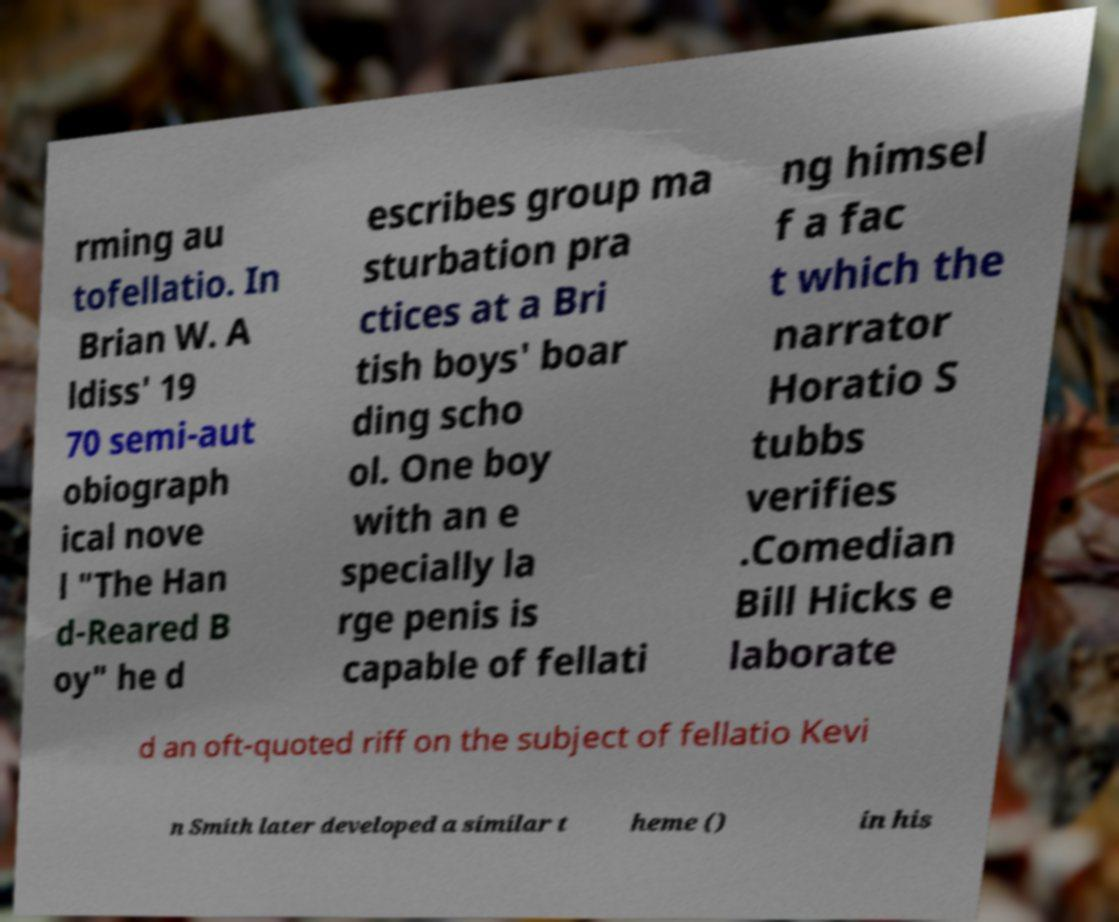Please read and relay the text visible in this image. What does it say? rming au tofellatio. In Brian W. A ldiss' 19 70 semi-aut obiograph ical nove l "The Han d-Reared B oy" he d escribes group ma sturbation pra ctices at a Bri tish boys' boar ding scho ol. One boy with an e specially la rge penis is capable of fellati ng himsel f a fac t which the narrator Horatio S tubbs verifies .Comedian Bill Hicks e laborate d an oft-quoted riff on the subject of fellatio Kevi n Smith later developed a similar t heme () in his 